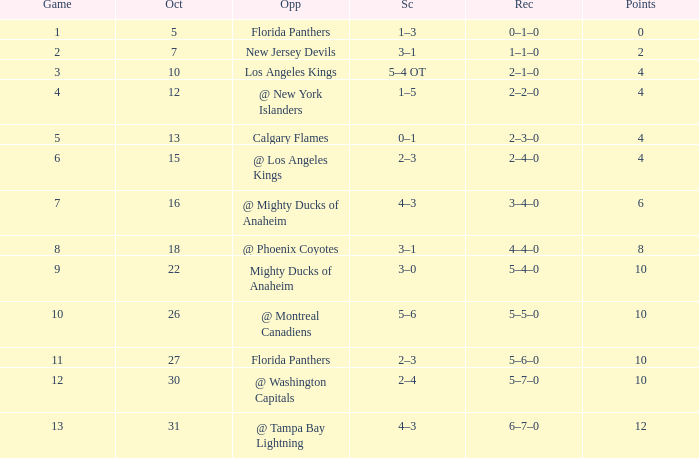What team has a score of 11 5–6–0. 